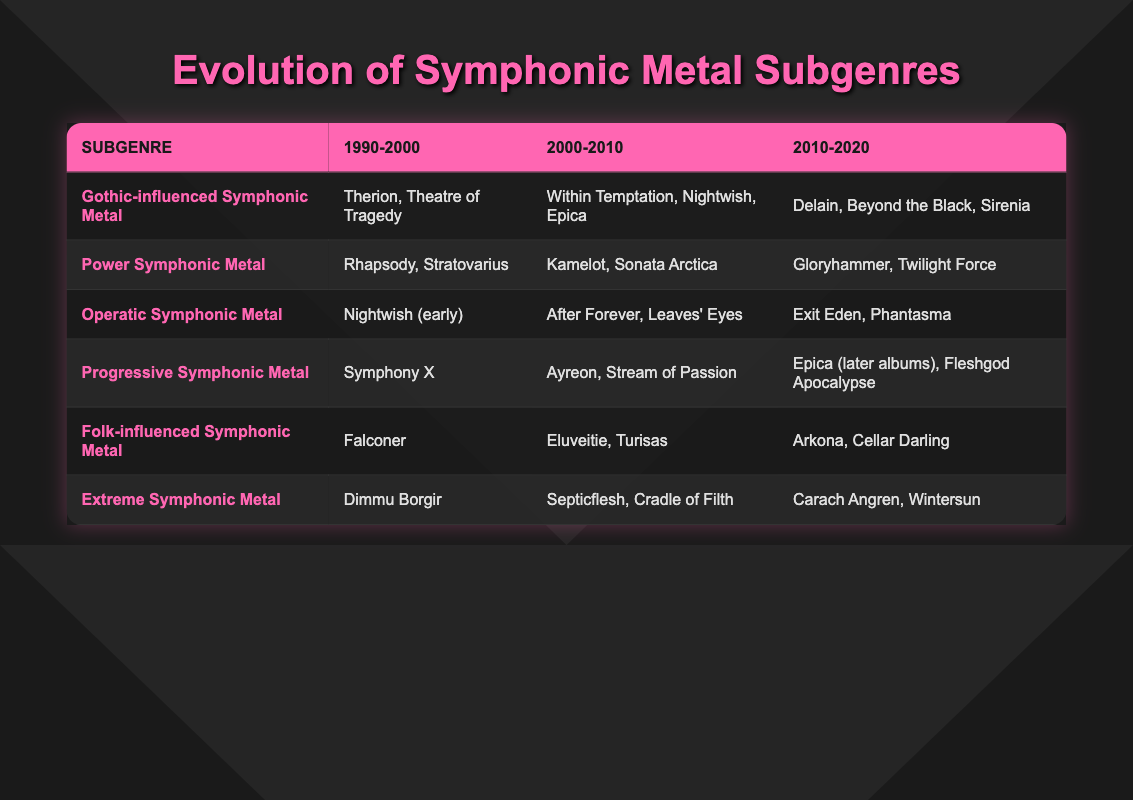What are the bands associated with Gothic-influenced Symphonic Metal from 2000 to 2010? The table lists the bands for Gothic-influenced Symphonic Metal during this period as Within Temptation, Nightwish, and Epica.
Answer: Within Temptation, Nightwish, Epica Which subgenre featured Dimmu Borgir in the 1990-2000 period? According to the table, Dimmu Borgir is noted under Extreme Symphonic Metal for the 1990-2000 period.
Answer: Extreme Symphonic Metal Did Power Symphonic Metal have any bands listed in the 2010-2020 period? Yes, the table shows that Gloryhammer and Twilight Force were the bands associated with Power Symphonic Metal in this period.
Answer: Yes What is the total number of unique bands listed for the Operatic Symphonic Metal subgenre across all periods? The bands for the Operatic Symphonic Metal are Nightwish (early), After Forever, Leaves' Eyes, Exit Eden, and Phantasma. Counting these gives us 5 unique bands.
Answer: 5 Which subgenre saw the introduction of Arkona and Cellar Darling from 2010 to 2020? In the table, the bands Arkona and Cellar Darling are listed under Folk-influenced Symphonic Metal for the 2010-2020 period.
Answer: Folk-influenced Symphonic Metal In which decade did Kamelot and Sonata Arctica make their appearance in the Power Symphonic Metal subgenre? The table indicates that Kamelot and Sonata Arctica were associated with Power Symphonic Metal in the decade from 2000 to 2010.
Answer: 2000-2010 Which subgenre has the maximum number of bands mentioned in the 2010-2020 category? By examining the table, the following subgenres in the 2010-2020 category have the following number of bands: Gothic-influenced has 3, Power has 2, Operatic has 2, Progressive has 2, Folk has 2, and Extreme has 2. Gothic-influenced Symphonic Metal has the most with 3 bands.
Answer: Gothic-influenced Symphonic Metal Are there any bands listed for Folk-influenced Symphonic Metal in the 1990-2000 period? The table shows only Falconer listed for the Folk-influenced Symphonic Metal in that period, therefore, yes, there are bands listed.
Answer: Yes Which two subgenres had the same bands listed during the 2000-2010 period? The table reveals that there are no subgenres with the same bands in the 2000-2010 period as each has distinct bands listed (e.g., Gothic-influenced has Within Temptation, while Power has Kamelot).
Answer: No 